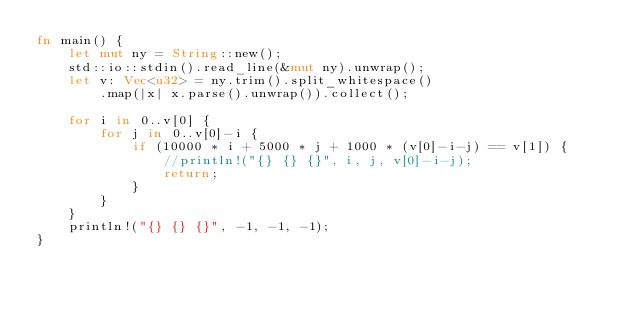Convert code to text. <code><loc_0><loc_0><loc_500><loc_500><_Rust_>fn main() {
    let mut ny = String::new();
    std::io::stdin().read_line(&mut ny).unwrap();
    let v: Vec<u32> = ny.trim().split_whitespace()
        .map(|x| x.parse().unwrap()).collect();

    for i in 0..v[0] {
        for j in 0..v[0]-i {
            if (10000 * i + 5000 * j + 1000 * (v[0]-i-j) == v[1]) {
                //println!("{} {} {}", i, j, v[0]-i-j);
                return;
            }
        }
    }
    println!("{} {} {}", -1, -1, -1);
}</code> 